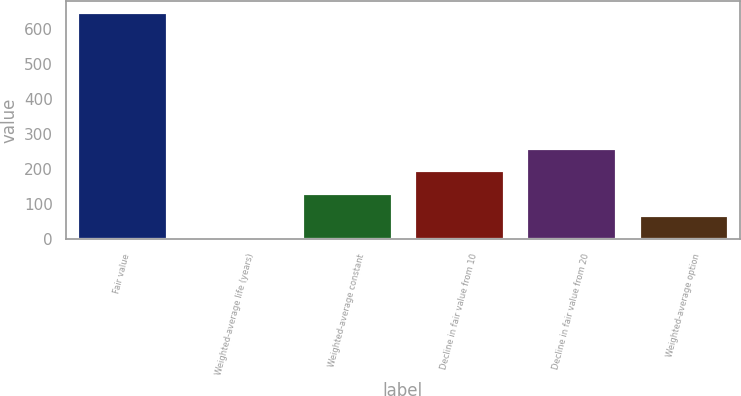Convert chart to OTSL. <chart><loc_0><loc_0><loc_500><loc_500><bar_chart><fcel>Fair value<fcel>Weighted-average life (years)<fcel>Weighted-average constant<fcel>Decline in fair value from 10<fcel>Decline in fair value from 20<fcel>Weighted-average option<nl><fcel>647<fcel>3.6<fcel>132.28<fcel>196.62<fcel>260.96<fcel>67.94<nl></chart> 